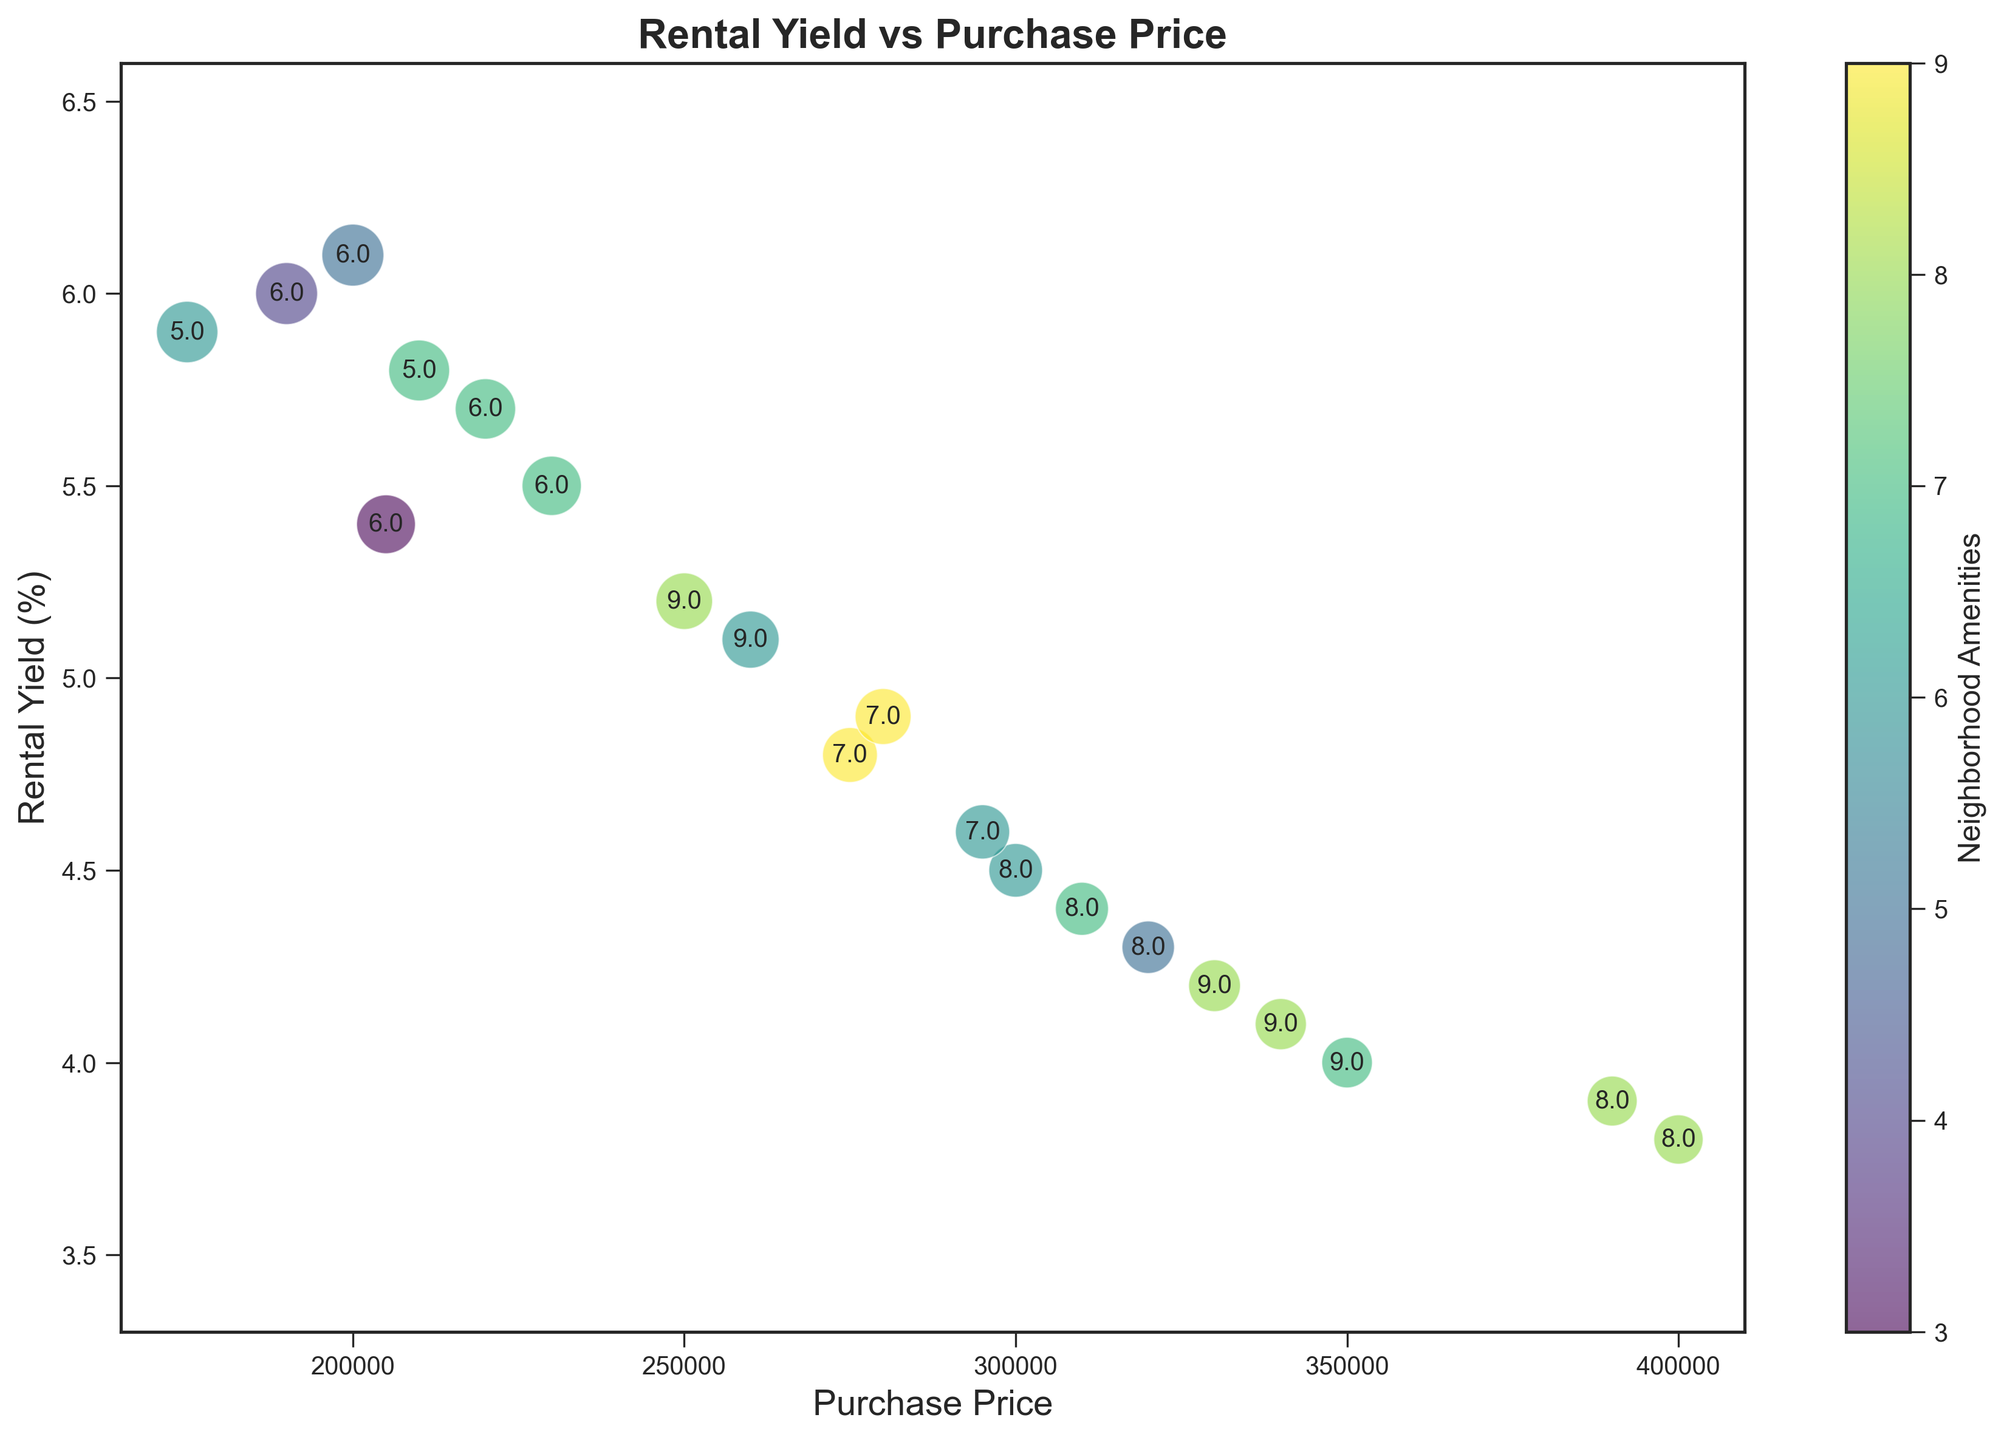What's the property with the highest rental yield? Looking at the y-axis, the highest rental yield appears at the top—6.1%. The corresponding purchase price is $200,000.
Answer: $200,000 Which property has the highest neighborhood amenities score? The color bar shows that the darkest green bubbles represent the highest neighborhood amenities score of 9. We see that properties with purchase prices of $275,000, $280,000, $330,000, and $340,000 have this highest score.
Answer: $275,000, $280,000, $330,000, $340,000 What is the rental yield of the property with a purchase price of $390,000? Locate the purchase price of $390,000 on the x-axis and trace upwards to the corresponding bubble—3.9%.
Answer: 3.9% Which property has the largest bubble size, indicating the highest school rating? The annotation inside each bubble represents school ratings. The largest combination of bubble size and annotation value is for purchase prices less than $200,000. The one with the highest rating (numeric inside the largest bubble) has a purchase price of $190,000.
Answer: $190,000 What is the range in rental yield between the highest and lowest yielding properties? The highest rental yield is 6.1%, and the lowest is 3.8%. The range is 6.1% - 3.8% = 2.3%.
Answer: 2.3% Which properties have school ratings of 9? By referring to the annotated numbers within the bubbles, properties with purchase prices of $250,000, $350,000, $260,000, and $330,000 have school ratings of 9.
Answer: $250,000, $350,000, $260,000, $330,000 Which property has the highest combination of rental yield and neighborhood amenities score? Rental yield can be determined by the y-axis, and neighborhood amenities can be distinguished by the bubble's color. The property with the highest rental yield (6.1%) has a moderate neighborhood amenities score of 5, while the highest overall colored bubble (9 amenities) combined with a reasonably high rental yield occurs at a purchase price of $275,000 and 4.8% yield. However, $300,000 with a yield of 5.2 and $250,000 with a yield and amenities score of 8 could also be considered high.
Answer: $250,000 What is the average rental yield for properties with a purchase price below $250,000? Identify all properties below $250,000 (7 properties total: $175,000, $200,000, $220,000, $190,000, $210,000, $205,000, $230,000) with yields (5.9%, 6.1%, 5.7%, 6.0%, 5.8%, 5.4%, 5.5%). Their sum is 40.4%. Average yield is 40.4% / 7 = 5.77%.
Answer: 5.77% Which property has the smallest bubble size and what is its purchase price? The smallest bubble corresponds to the purchase price of $400,000.
Answer: $400,000 